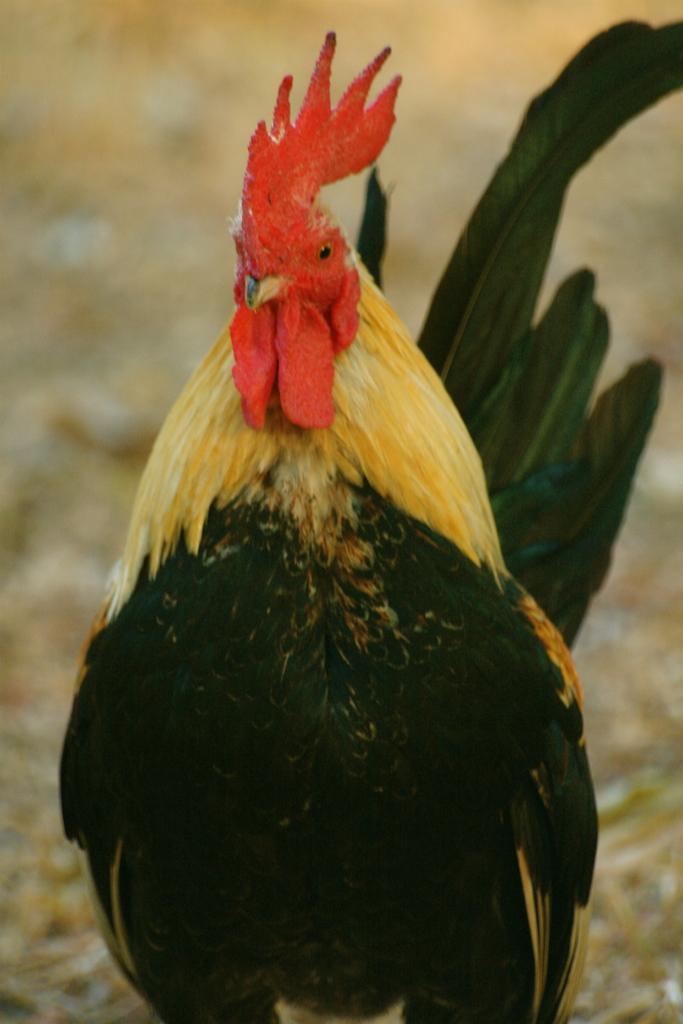Can you describe this image briefly? There is one cock is present in the middle of this image. 